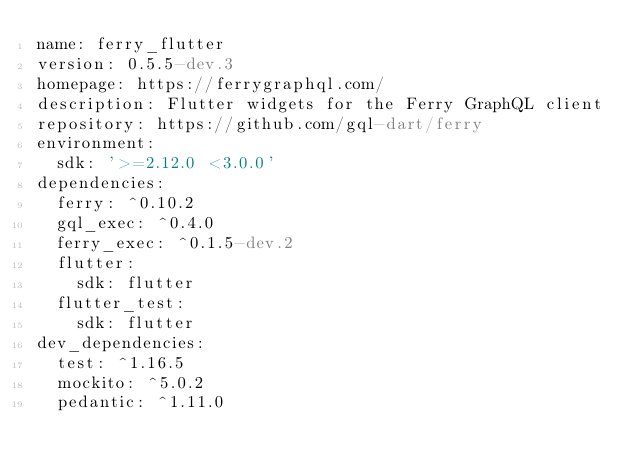<code> <loc_0><loc_0><loc_500><loc_500><_YAML_>name: ferry_flutter
version: 0.5.5-dev.3
homepage: https://ferrygraphql.com/
description: Flutter widgets for the Ferry GraphQL client
repository: https://github.com/gql-dart/ferry
environment:
  sdk: '>=2.12.0 <3.0.0'
dependencies:
  ferry: ^0.10.2
  gql_exec: ^0.4.0
  ferry_exec: ^0.1.5-dev.2
  flutter:
    sdk: flutter
  flutter_test:
    sdk: flutter
dev_dependencies:
  test: ^1.16.5
  mockito: ^5.0.2
  pedantic: ^1.11.0
</code> 